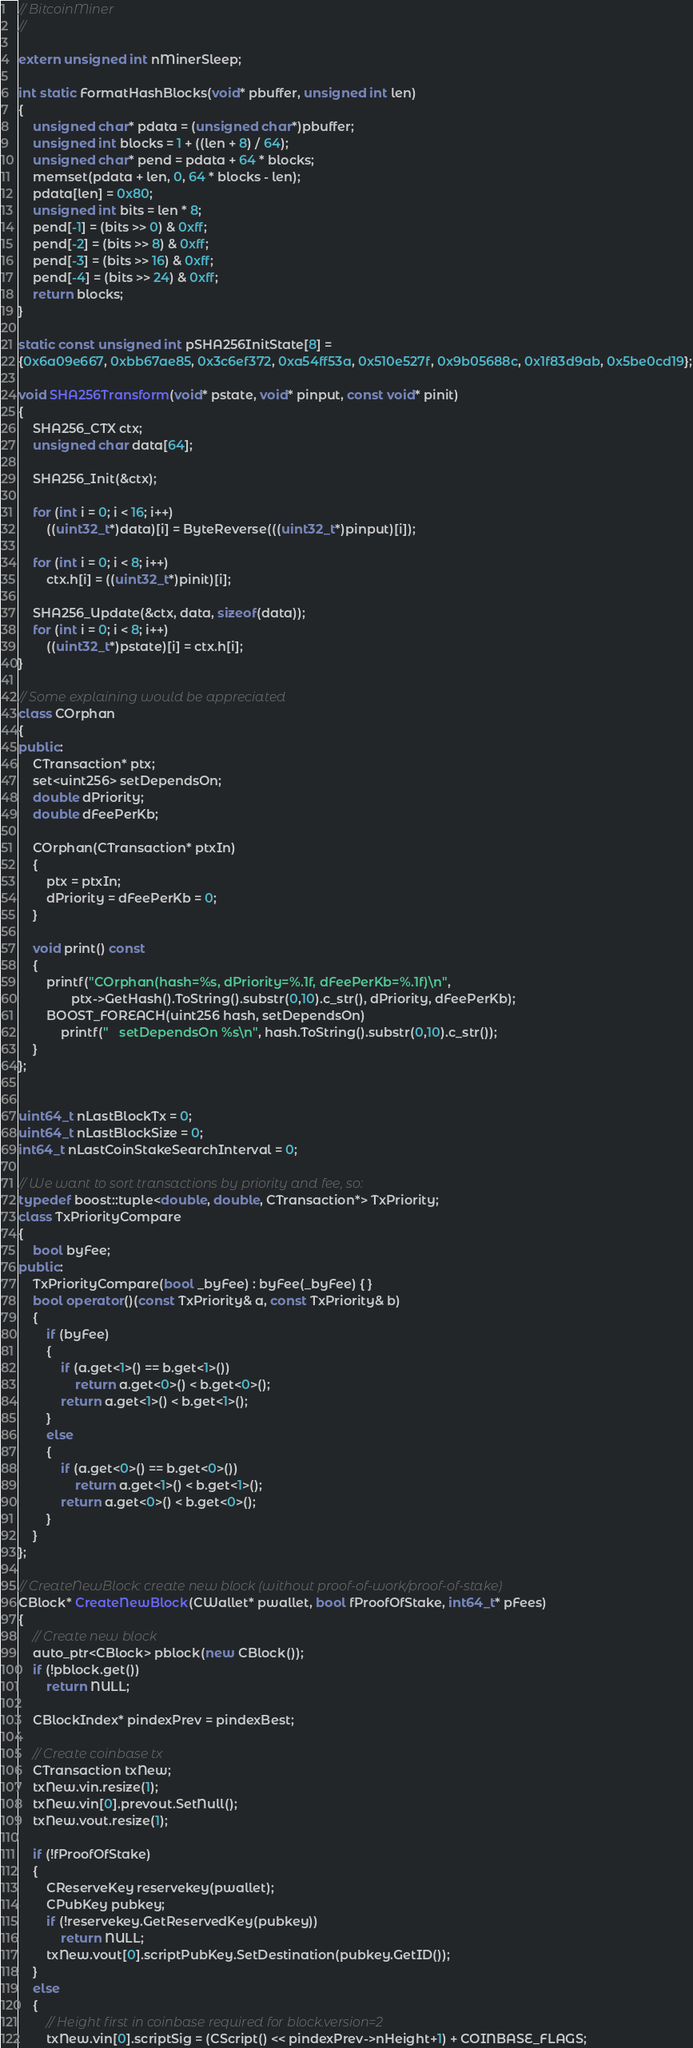Convert code to text. <code><loc_0><loc_0><loc_500><loc_500><_C++_>// BitcoinMiner
//

extern unsigned int nMinerSleep;

int static FormatHashBlocks(void* pbuffer, unsigned int len)
{
    unsigned char* pdata = (unsigned char*)pbuffer;
    unsigned int blocks = 1 + ((len + 8) / 64);
    unsigned char* pend = pdata + 64 * blocks;
    memset(pdata + len, 0, 64 * blocks - len);
    pdata[len] = 0x80;
    unsigned int bits = len * 8;
    pend[-1] = (bits >> 0) & 0xff;
    pend[-2] = (bits >> 8) & 0xff;
    pend[-3] = (bits >> 16) & 0xff;
    pend[-4] = (bits >> 24) & 0xff;
    return blocks;
}

static const unsigned int pSHA256InitState[8] =
{0x6a09e667, 0xbb67ae85, 0x3c6ef372, 0xa54ff53a, 0x510e527f, 0x9b05688c, 0x1f83d9ab, 0x5be0cd19};

void SHA256Transform(void* pstate, void* pinput, const void* pinit)
{
    SHA256_CTX ctx;
    unsigned char data[64];

    SHA256_Init(&ctx);

    for (int i = 0; i < 16; i++)
        ((uint32_t*)data)[i] = ByteReverse(((uint32_t*)pinput)[i]);

    for (int i = 0; i < 8; i++)
        ctx.h[i] = ((uint32_t*)pinit)[i];

    SHA256_Update(&ctx, data, sizeof(data));
    for (int i = 0; i < 8; i++)
        ((uint32_t*)pstate)[i] = ctx.h[i];
}

// Some explaining would be appreciated
class COrphan
{
public:
    CTransaction* ptx;
    set<uint256> setDependsOn;
    double dPriority;
    double dFeePerKb;

    COrphan(CTransaction* ptxIn)
    {
        ptx = ptxIn;
        dPriority = dFeePerKb = 0;
    }

    void print() const
    {
        printf("COrphan(hash=%s, dPriority=%.1f, dFeePerKb=%.1f)\n",
               ptx->GetHash().ToString().substr(0,10).c_str(), dPriority, dFeePerKb);
        BOOST_FOREACH(uint256 hash, setDependsOn)
            printf("   setDependsOn %s\n", hash.ToString().substr(0,10).c_str());
    }
};


uint64_t nLastBlockTx = 0;
uint64_t nLastBlockSize = 0;
int64_t nLastCoinStakeSearchInterval = 0;
 
// We want to sort transactions by priority and fee, so:
typedef boost::tuple<double, double, CTransaction*> TxPriority;
class TxPriorityCompare
{
    bool byFee;
public:
    TxPriorityCompare(bool _byFee) : byFee(_byFee) { }
    bool operator()(const TxPriority& a, const TxPriority& b)
    {
        if (byFee)
        {
            if (a.get<1>() == b.get<1>())
                return a.get<0>() < b.get<0>();
            return a.get<1>() < b.get<1>();
        }
        else
        {
            if (a.get<0>() == b.get<0>())
                return a.get<1>() < b.get<1>();
            return a.get<0>() < b.get<0>();
        }
    }
};

// CreateNewBlock: create new block (without proof-of-work/proof-of-stake)
CBlock* CreateNewBlock(CWallet* pwallet, bool fProofOfStake, int64_t* pFees)
{
    // Create new block
    auto_ptr<CBlock> pblock(new CBlock());
    if (!pblock.get())
        return NULL;

    CBlockIndex* pindexPrev = pindexBest;

    // Create coinbase tx
    CTransaction txNew;
    txNew.vin.resize(1);
    txNew.vin[0].prevout.SetNull();
    txNew.vout.resize(1);

    if (!fProofOfStake)
    {
        CReserveKey reservekey(pwallet);
        CPubKey pubkey;
        if (!reservekey.GetReservedKey(pubkey))
            return NULL;
        txNew.vout[0].scriptPubKey.SetDestination(pubkey.GetID());
    }
    else
    {
        // Height first in coinbase required for block.version=2
        txNew.vin[0].scriptSig = (CScript() << pindexPrev->nHeight+1) + COINBASE_FLAGS;</code> 